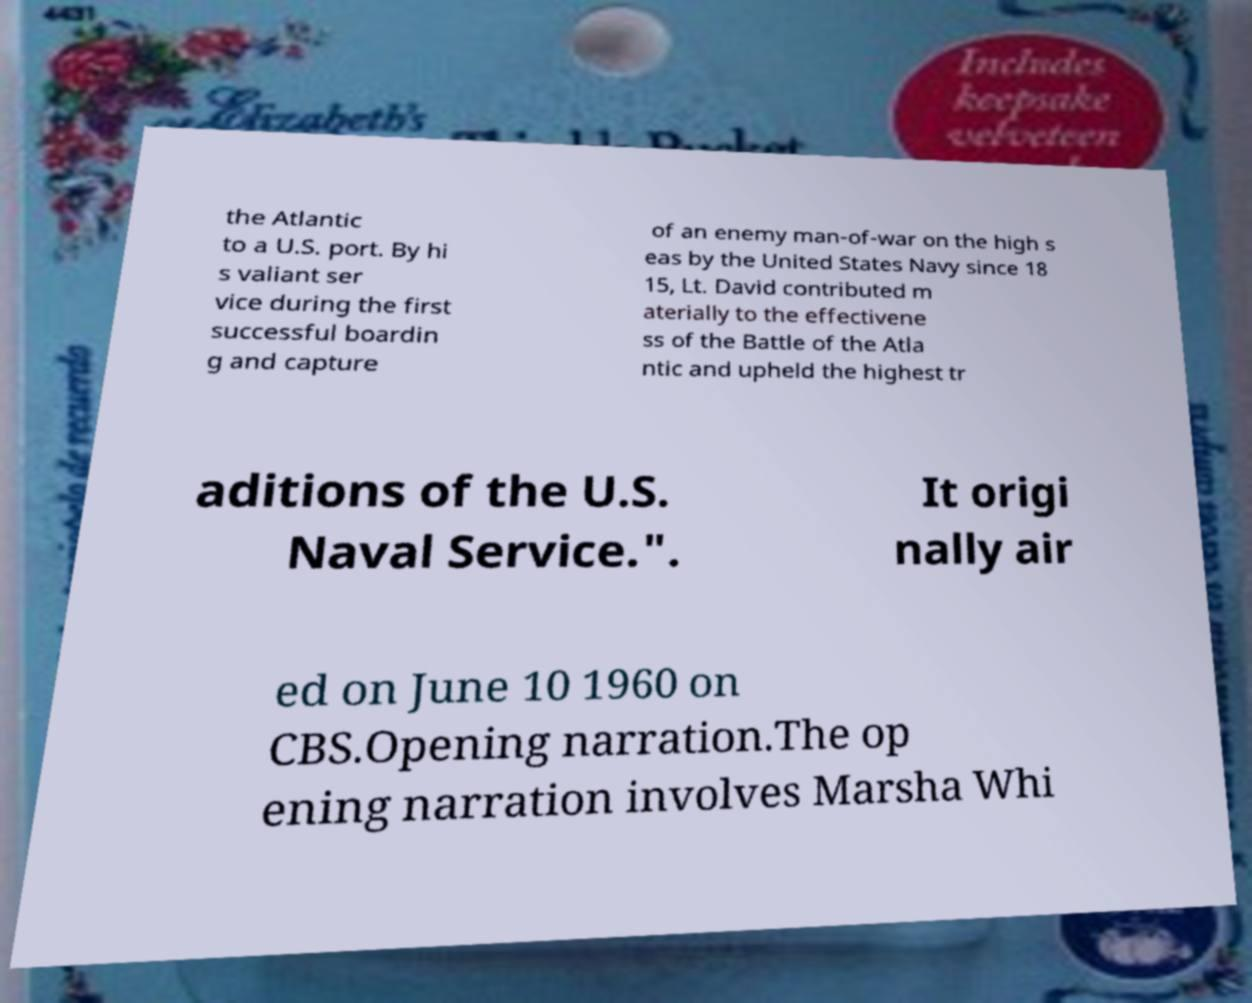What messages or text are displayed in this image? I need them in a readable, typed format. the Atlantic to a U.S. port. By hi s valiant ser vice during the first successful boardin g and capture of an enemy man-of-war on the high s eas by the United States Navy since 18 15, Lt. David contributed m aterially to the effectivene ss of the Battle of the Atla ntic and upheld the highest tr aditions of the U.S. Naval Service.". It origi nally air ed on June 10 1960 on CBS.Opening narration.The op ening narration involves Marsha Whi 